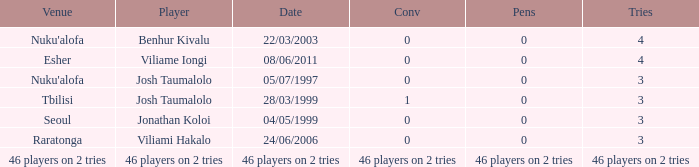What date did Josh Taumalolo play at Nuku'alofa? 05/07/1997. 